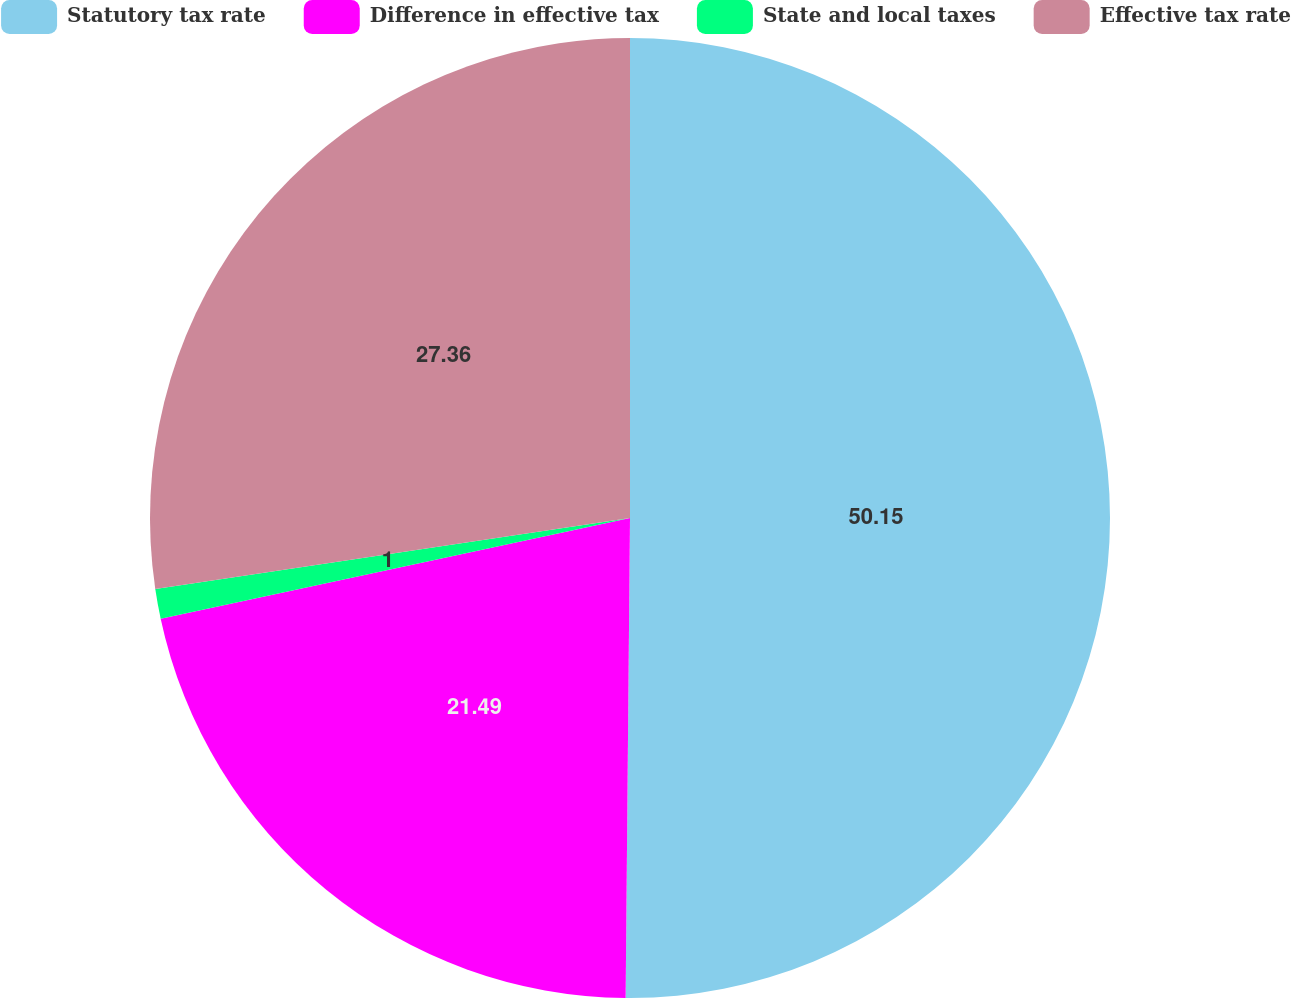Convert chart. <chart><loc_0><loc_0><loc_500><loc_500><pie_chart><fcel>Statutory tax rate<fcel>Difference in effective tax<fcel>State and local taxes<fcel>Effective tax rate<nl><fcel>50.14%<fcel>21.49%<fcel>1.0%<fcel>27.36%<nl></chart> 